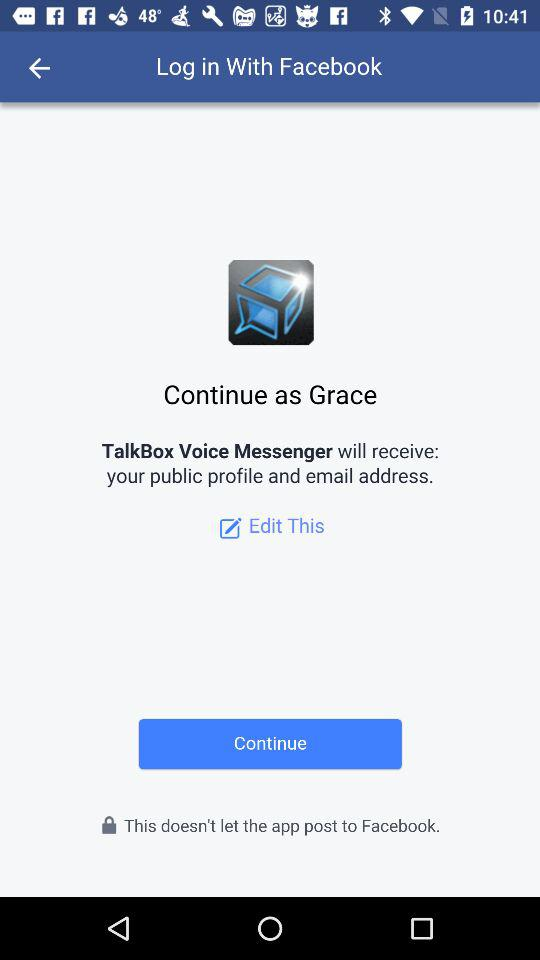What application is asking for permission? The application asking for permission is "TalkBox Voice Messenger". 